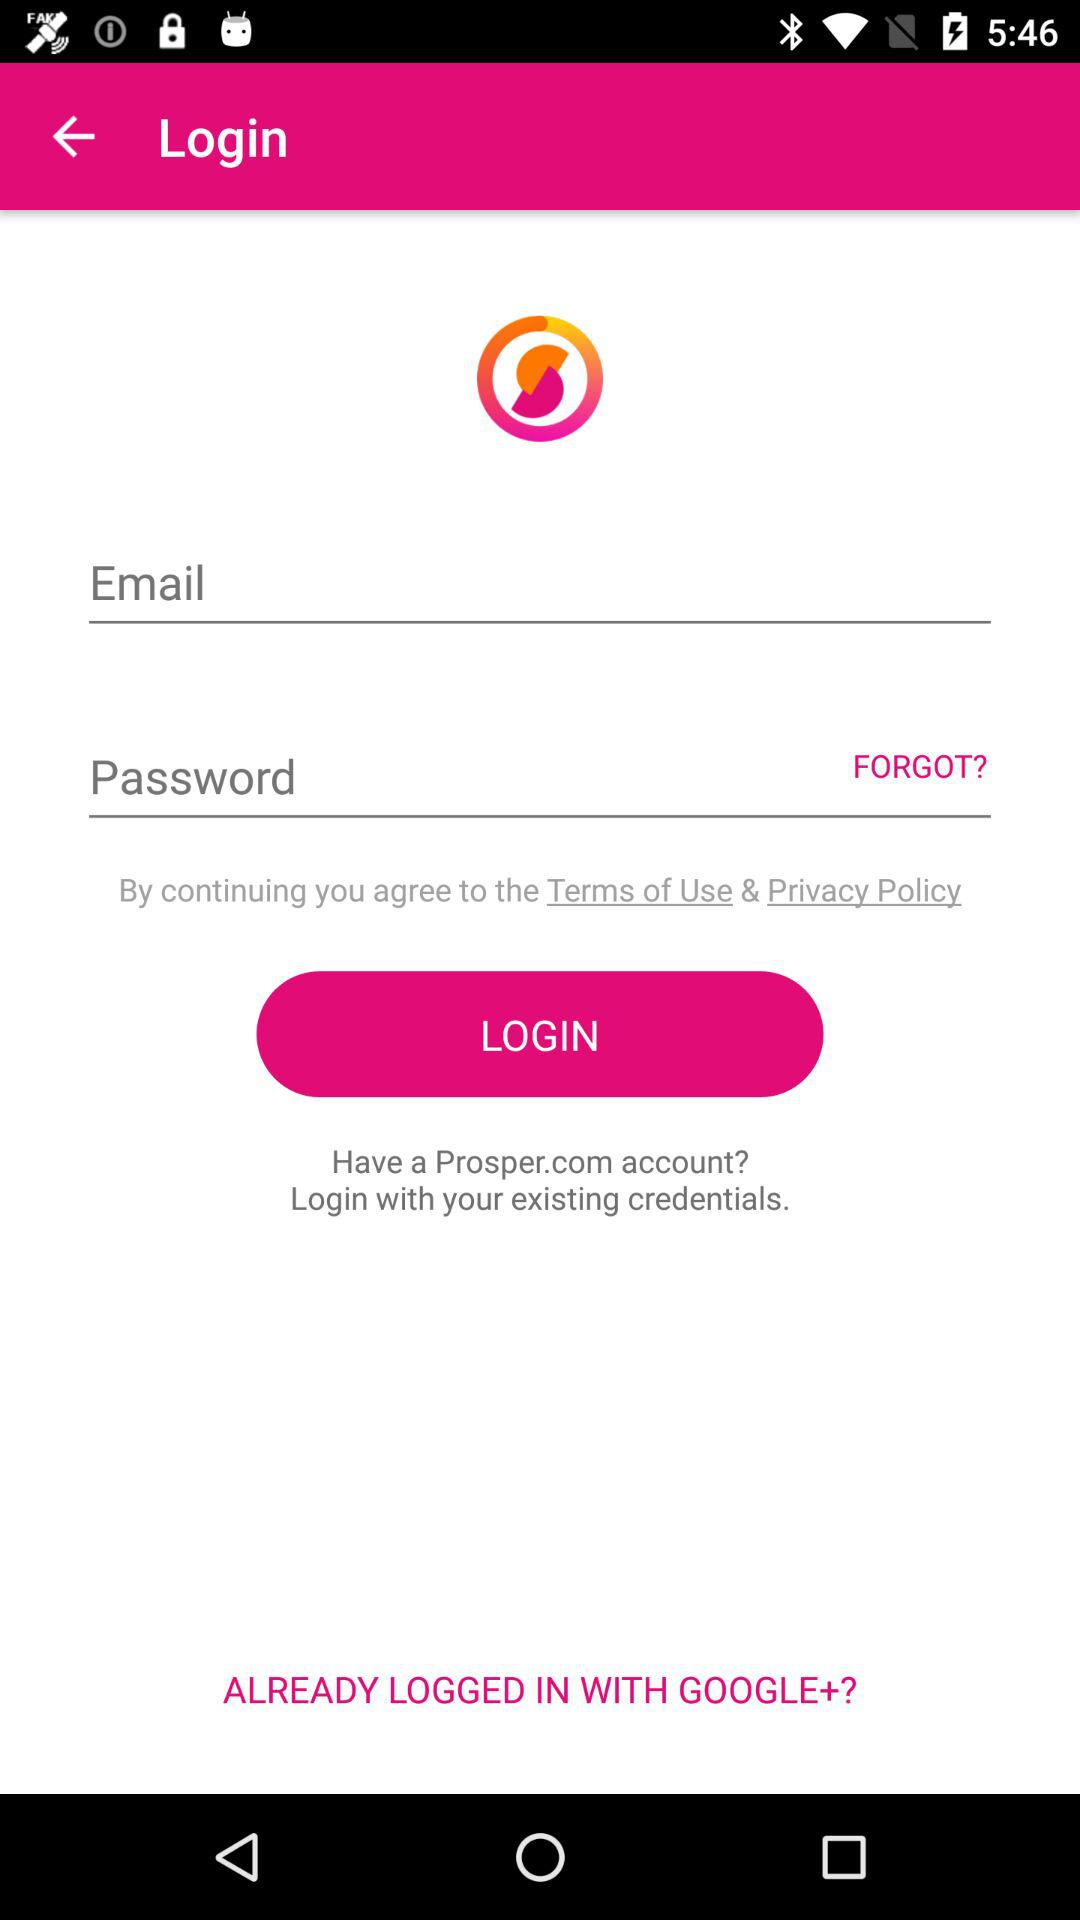How many fields are required to login?
Answer the question using a single word or phrase. 2 